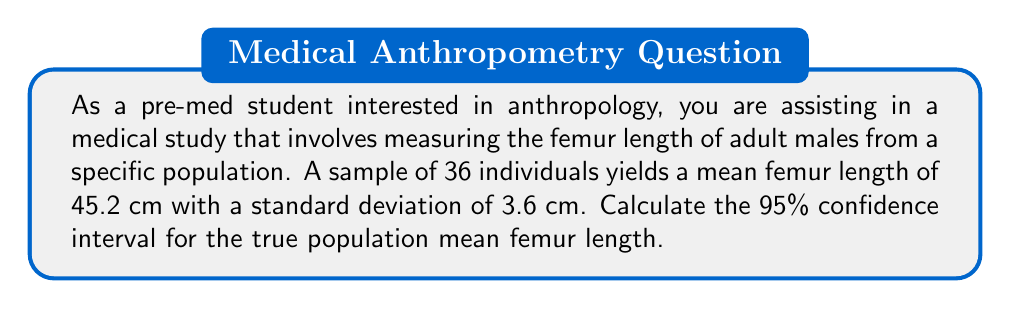Solve this math problem. To calculate the confidence interval, we'll use the formula:

$$ \text{CI} = \bar{x} \pm t_{\alpha/2} \cdot \frac{s}{\sqrt{n}} $$

Where:
- $\bar{x}$ is the sample mean
- $t_{\alpha/2}$ is the t-value for a 95% confidence level with n-1 degrees of freedom
- $s$ is the sample standard deviation
- $n$ is the sample size

Step 1: Identify the known values
- $\bar{x} = 45.2$ cm
- $s = 3.6$ cm
- $n = 36$
- Confidence level = 95%

Step 2: Determine the t-value
For a 95% confidence level and 35 degrees of freedom (n-1 = 35), the t-value is approximately 2.030.

Step 3: Calculate the margin of error
$$ \text{Margin of Error} = t_{\alpha/2} \cdot \frac{s}{\sqrt{n}} = 2.030 \cdot \frac{3.6}{\sqrt{36}} = 1.22 $$

Step 4: Calculate the confidence interval
$$ \text{CI} = 45.2 \pm 1.22 $$

Lower bound: $45.2 - 1.22 = 43.98$ cm
Upper bound: $45.2 + 1.22 = 46.42$ cm
Answer: The 95% confidence interval for the true population mean femur length is (43.98 cm, 46.42 cm). 